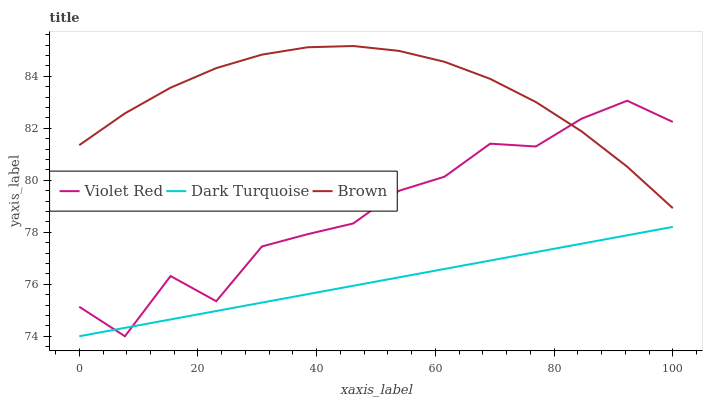Does Violet Red have the minimum area under the curve?
Answer yes or no. No. Does Violet Red have the maximum area under the curve?
Answer yes or no. No. Is Brown the smoothest?
Answer yes or no. No. Is Brown the roughest?
Answer yes or no. No. Does Brown have the lowest value?
Answer yes or no. No. Does Violet Red have the highest value?
Answer yes or no. No. Is Dark Turquoise less than Brown?
Answer yes or no. Yes. Is Brown greater than Dark Turquoise?
Answer yes or no. Yes. Does Dark Turquoise intersect Brown?
Answer yes or no. No. 